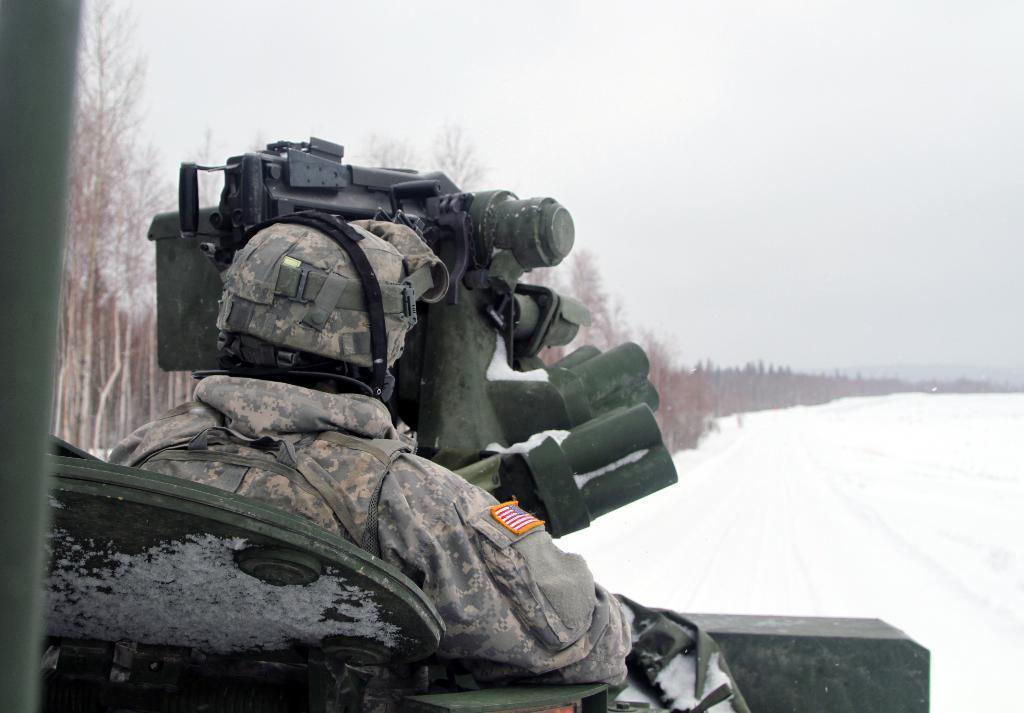Describe this image in one or two sentences. In the picture we can see the army man in the uniform and holding some equipment and in front of him we can see the snow surface and beside it, we can see full of trees and in the background we can see the sky. 